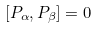Convert formula to latex. <formula><loc_0><loc_0><loc_500><loc_500>[ P _ { \alpha } , P _ { \beta } ] = 0</formula> 